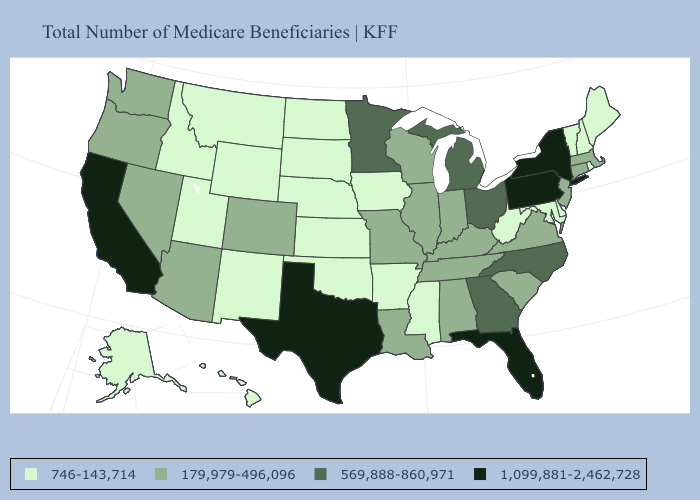What is the value of Maryland?
Write a very short answer. 746-143,714. Among the states that border Kansas , does Colorado have the lowest value?
Write a very short answer. No. What is the value of Colorado?
Concise answer only. 179,979-496,096. Does Kansas have a higher value than North Carolina?
Be succinct. No. What is the value of Maryland?
Keep it brief. 746-143,714. Name the states that have a value in the range 1,099,881-2,462,728?
Answer briefly. California, Florida, New York, Pennsylvania, Texas. Does the map have missing data?
Be succinct. No. Name the states that have a value in the range 746-143,714?
Keep it brief. Alaska, Arkansas, Delaware, Hawaii, Idaho, Iowa, Kansas, Maine, Maryland, Mississippi, Montana, Nebraska, New Hampshire, New Mexico, North Dakota, Oklahoma, Rhode Island, South Dakota, Utah, Vermont, West Virginia, Wyoming. What is the value of Alaska?
Keep it brief. 746-143,714. What is the lowest value in states that border Wisconsin?
Short answer required. 746-143,714. Does New Mexico have the highest value in the USA?
Keep it brief. No. What is the value of Pennsylvania?
Short answer required. 1,099,881-2,462,728. What is the value of Nebraska?
Be succinct. 746-143,714. What is the value of Washington?
Quick response, please. 179,979-496,096. Does South Carolina have the lowest value in the USA?
Give a very brief answer. No. 